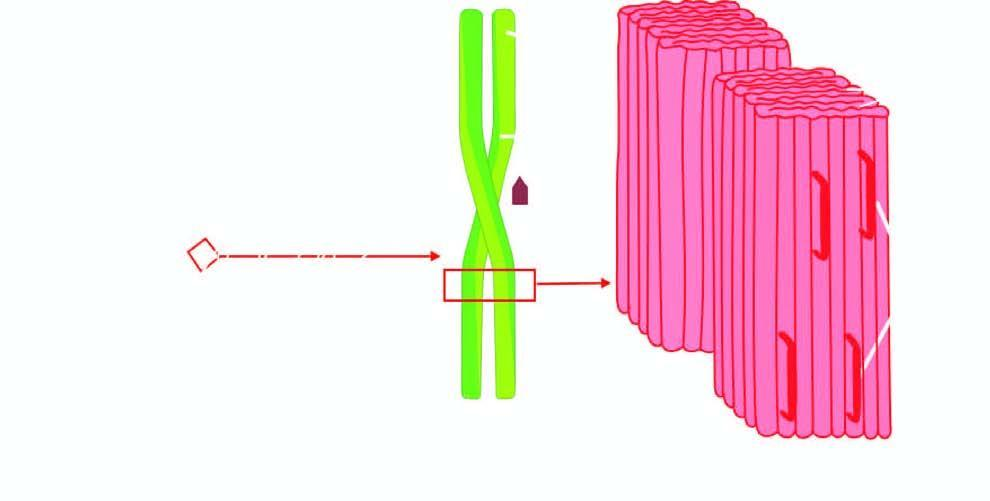does c, x-ray crystallography and infra-red spectroscopy show fibrils having cross -- pleated sheet configuration which produces periodicity that gives the characteristic staining properties of amyloid with congo red and birefringence under polarising mic
Answer the question using a single word or phrase. Yes 